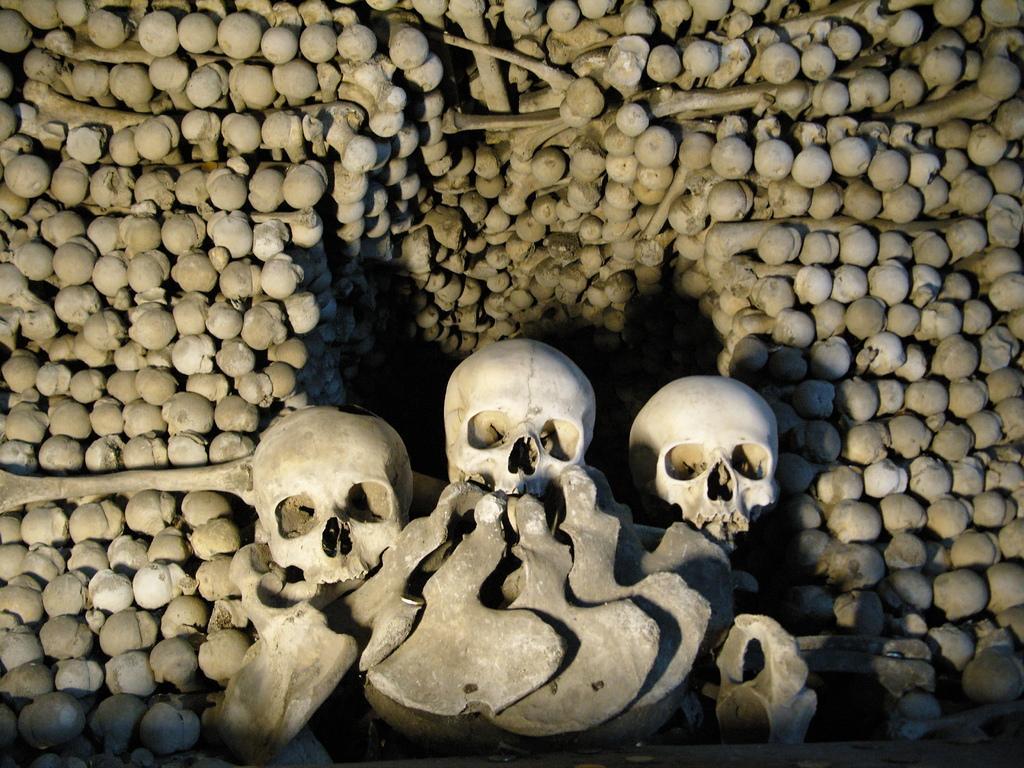Describe this image in one or two sentences. In this picture I can observe three skulls. I can observe bones in this picture. 